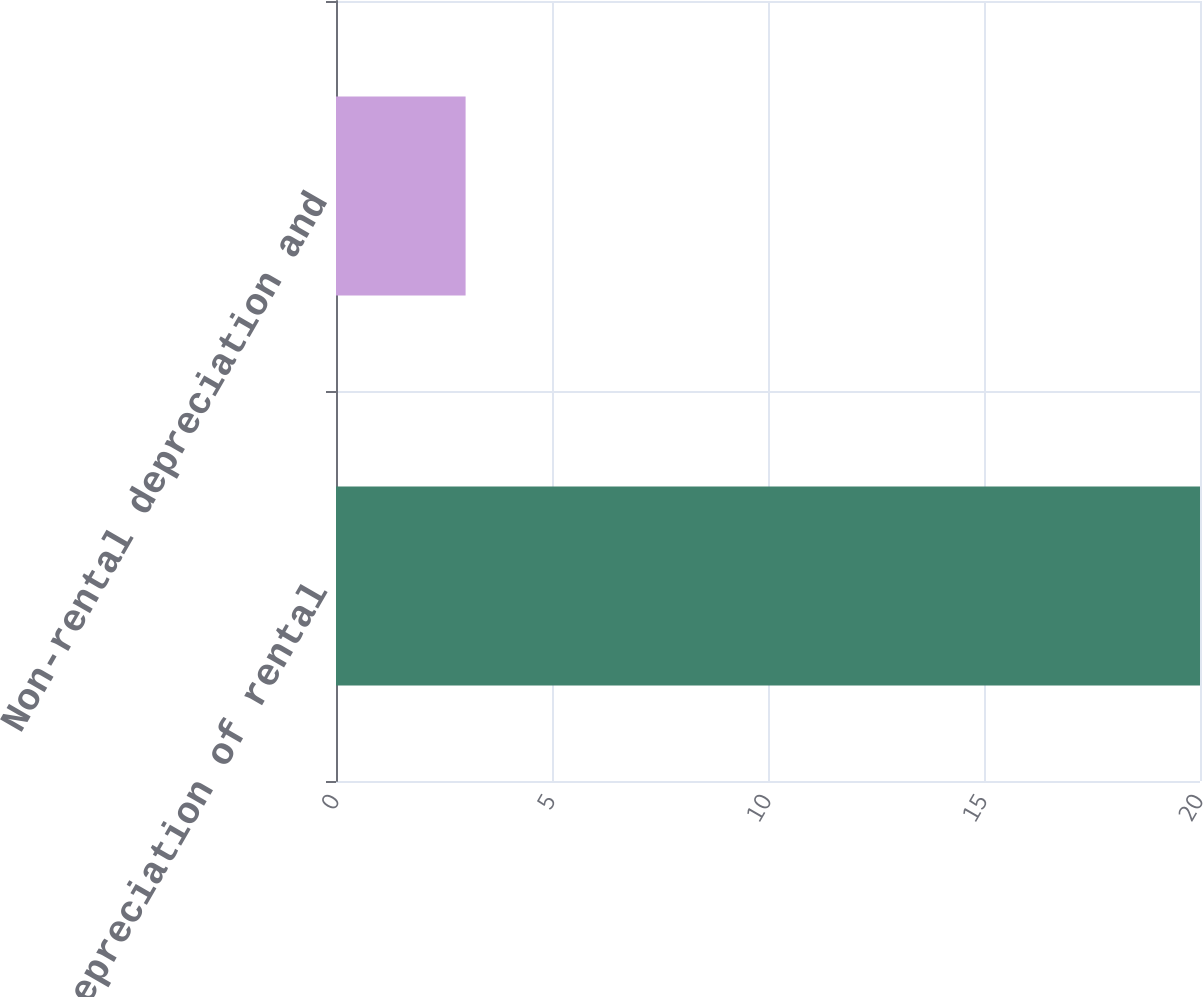Convert chart. <chart><loc_0><loc_0><loc_500><loc_500><bar_chart><fcel>Depreciation of rental<fcel>Non-rental depreciation and<nl><fcel>20<fcel>3<nl></chart> 